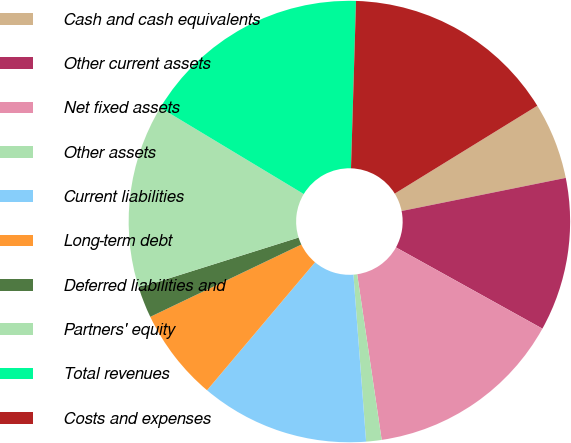Convert chart to OTSL. <chart><loc_0><loc_0><loc_500><loc_500><pie_chart><fcel>Cash and cash equivalents<fcel>Other current assets<fcel>Net fixed assets<fcel>Other assets<fcel>Current liabilities<fcel>Long-term debt<fcel>Deferred liabilities and<fcel>Partners' equity<fcel>Total revenues<fcel>Costs and expenses<nl><fcel>5.62%<fcel>11.23%<fcel>14.6%<fcel>1.13%<fcel>12.36%<fcel>6.74%<fcel>2.25%<fcel>13.48%<fcel>16.85%<fcel>15.73%<nl></chart> 